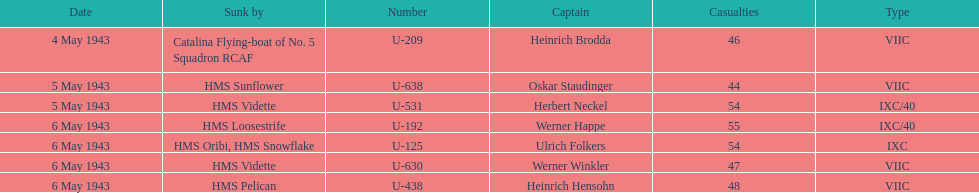Which u-boat had more than 54 casualties? U-192. 